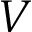Convert formula to latex. <formula><loc_0><loc_0><loc_500><loc_500>V</formula> 